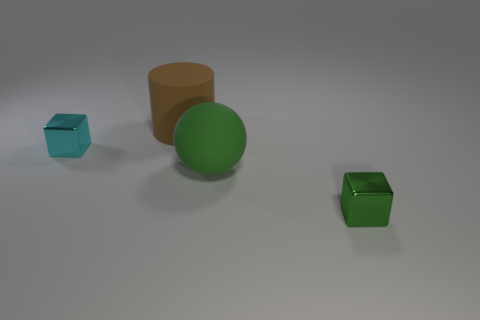What number of big things are either cyan blocks or matte things? In the image, there are no big, cyan blocks present. We can see one big matte object, which is the green sphere, and two smaller matte objects, which are green and cyan colored blocks. Therefore, the number of big matte things in the image is one. 